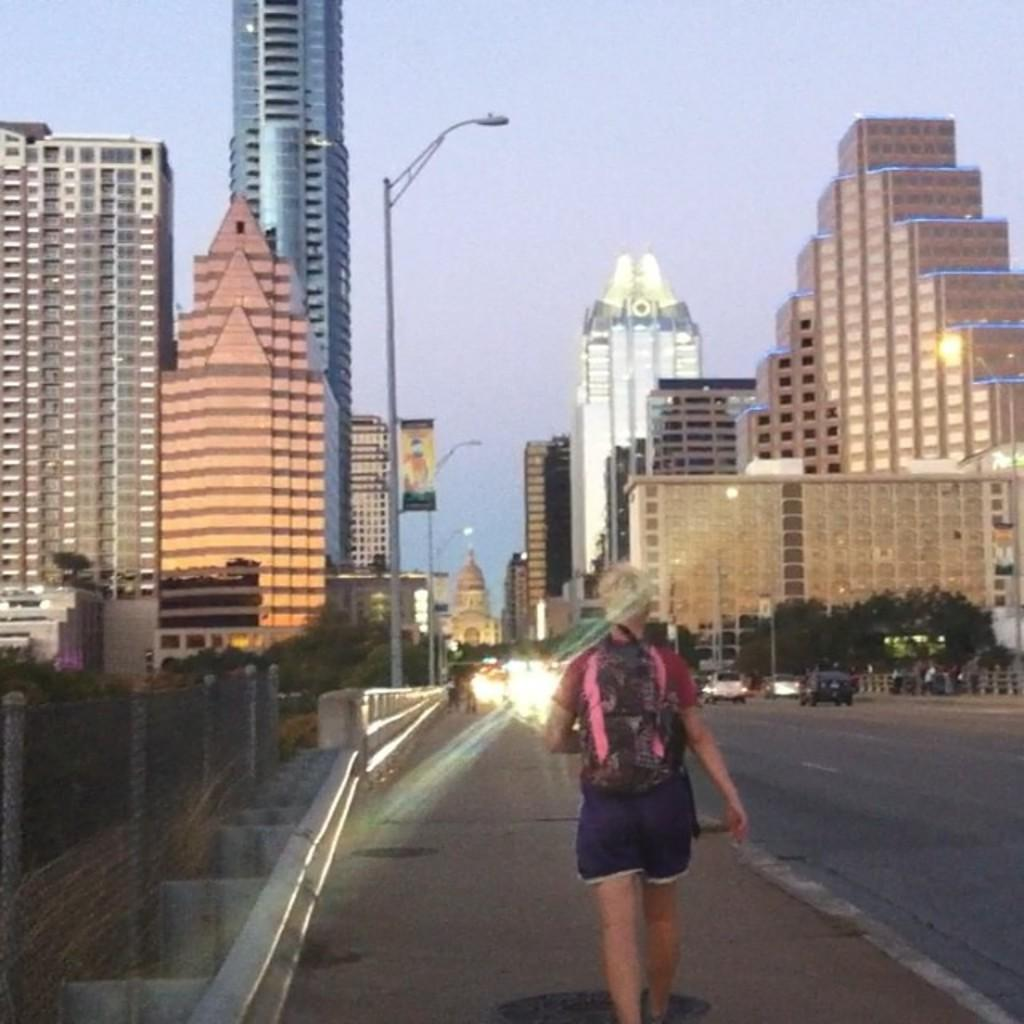Who is present in the image? There is a person in the image. What is the person wearing? The person is wearing a bag. What is the person doing in the image? The person is walking. What can be seen in the background of the image? There are buildings, light-poles, vehicles, and trees visible in the background. What is the color of the sky in the image? The sky is blue in the image. How many seeds are planted in the image? There are no seeds present in the image. What type of debt is the person in the image facing? There is no indication of debt in the image; it only shows a person walking with a bag. 